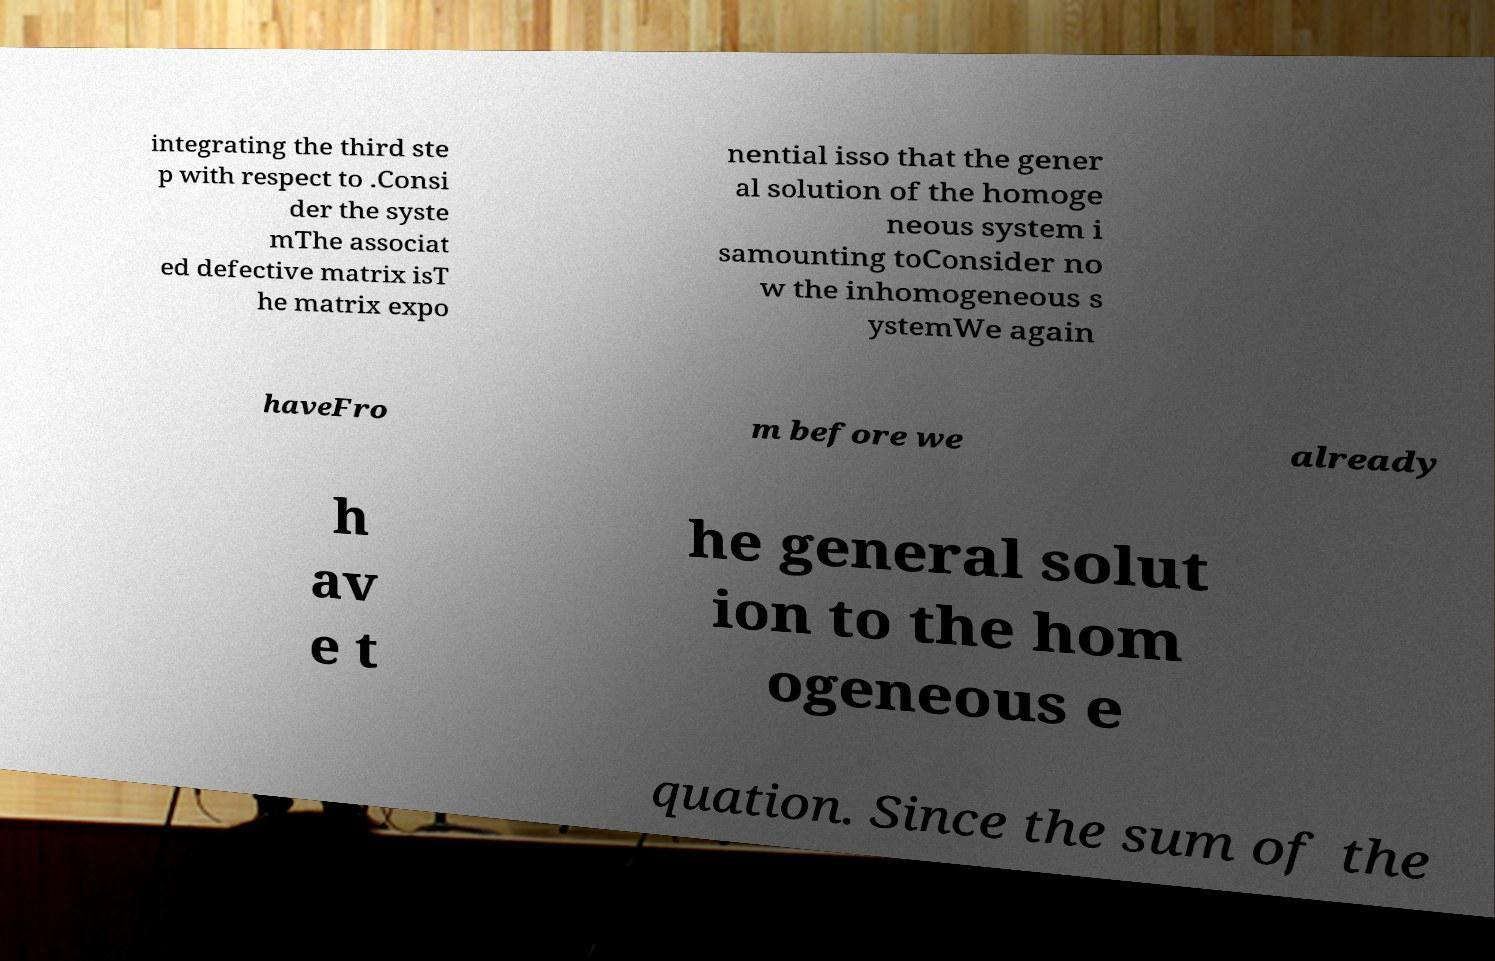There's text embedded in this image that I need extracted. Can you transcribe it verbatim? integrating the third ste p with respect to .Consi der the syste mThe associat ed defective matrix isT he matrix expo nential isso that the gener al solution of the homoge neous system i samounting toConsider no w the inhomogeneous s ystemWe again haveFro m before we already h av e t he general solut ion to the hom ogeneous e quation. Since the sum of the 